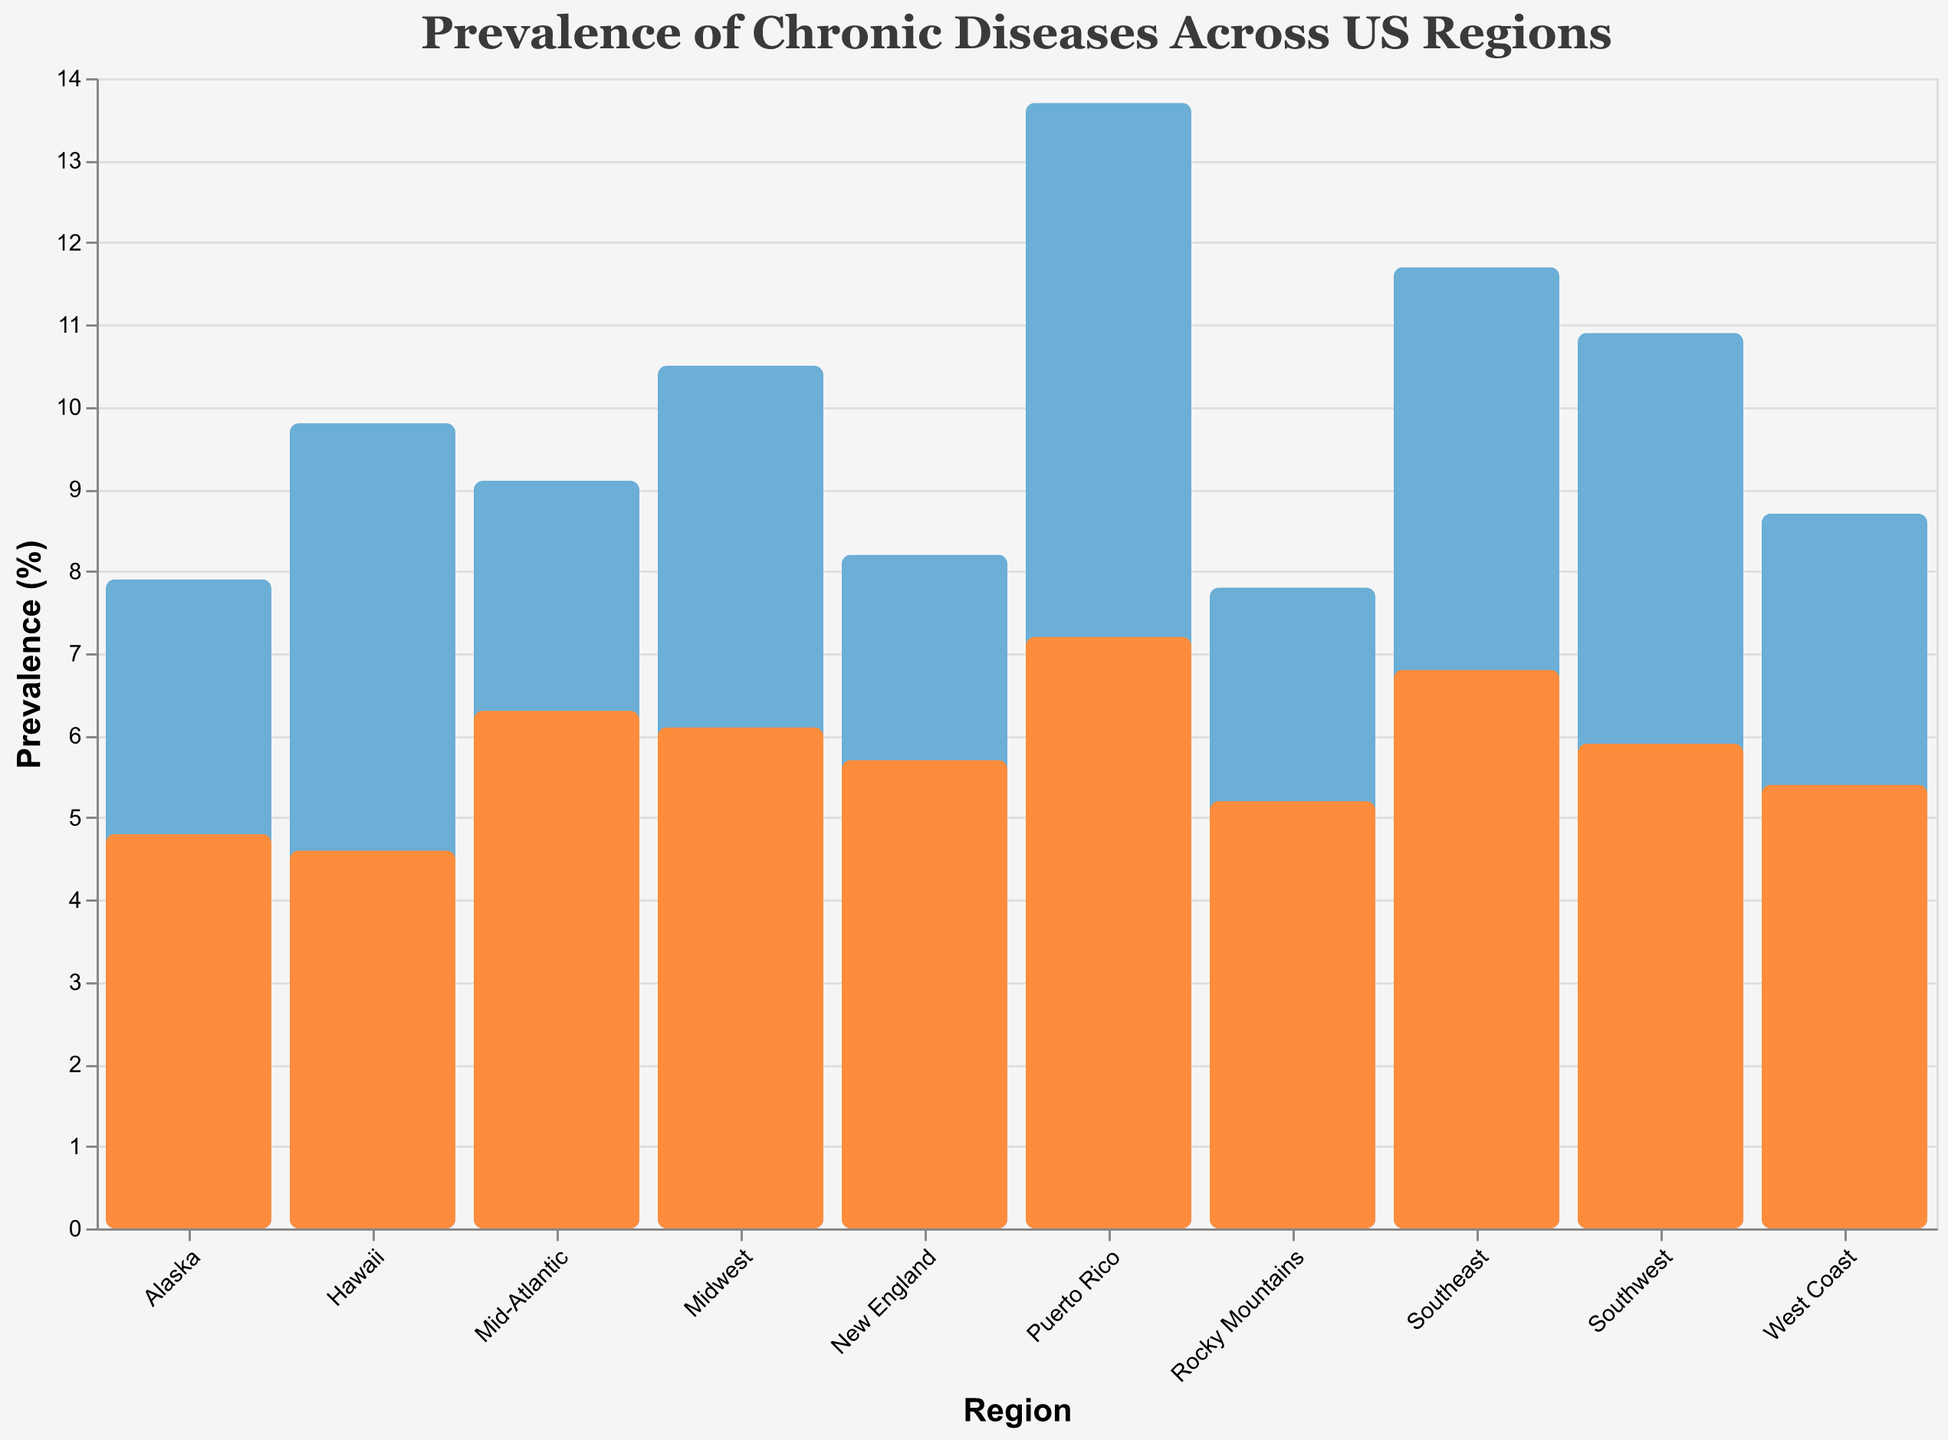What's the title of the plot? The title of the plot is usually displayed at the top and provides a summary of what the plot shows.
Answer: Prevalence of Chronic Diseases Across US Regions How many regions are displayed in the plot? The number of regions can be counted by looking at the x-axis labels.
Answer: 10 Which region has the highest diabetes prevalence? By comparing the heights of the blue bars, the region with the tallest bar has the highest diabetes prevalence.
Answer: Puerto Rico Which region has the lowest heart disease prevalence? By comparing the heights of the orange bars, the region with the shortest bar has the lowest heart disease prevalence.
Answer: Hawaii What's the difference in diabetes prevalence between Southeast and Mid-Atlantic? Look at the height of the blue bars for Southeast (11.7) and Mid-Atlantic (9.1), then subtract the smaller value from the larger one.
Answer: 2.6 What's the average heart disease prevalence in the New England, Mid-Atlantic, and Southeast regions? Sum the heart disease prevalence rates for New England (5.7), Mid-Atlantic (6.3), and Southeast (6.8). Then, divide by 3 to find the average: (5.7 + 6.3 + 6.8) / 3
Answer: 6.27 Is the diabetes prevalence in West Coast higher or lower than in Southwest? Compare the heights of the bars for West Coast (8.7) and Southwest (10.9) to find out which is higher.
Answer: Lower Which regions have both diabetes and heart disease prevalences below 6%? Check the bars for each region and identify those where both the blue and orange bars are below 6%.
Answer: Rocky Mountains, Alaska, Hawaii How does the heart disease prevalence in Puerto Rico compare to the heart disease prevalence in Alaska? Compare the heights of the orange bars for Puerto Rico (7.2) and Alaska (4.8).
Answer: Higher 